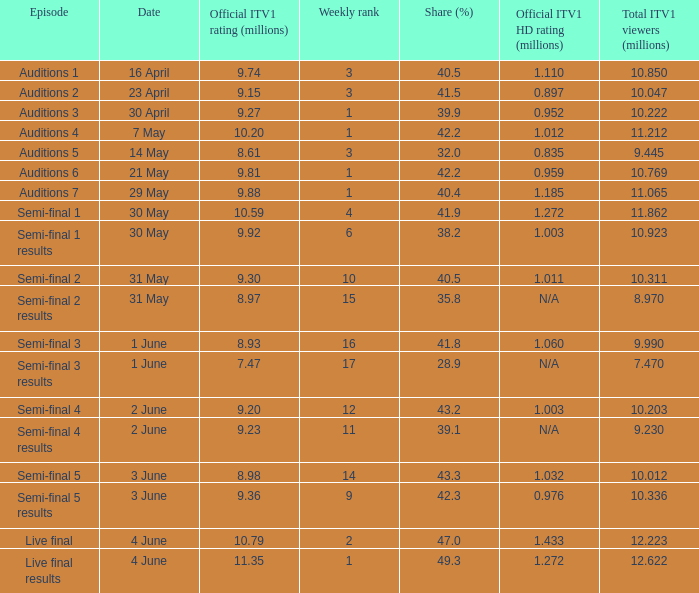What was the share (%) for the Semi-Final 2 episode?  40.5. 